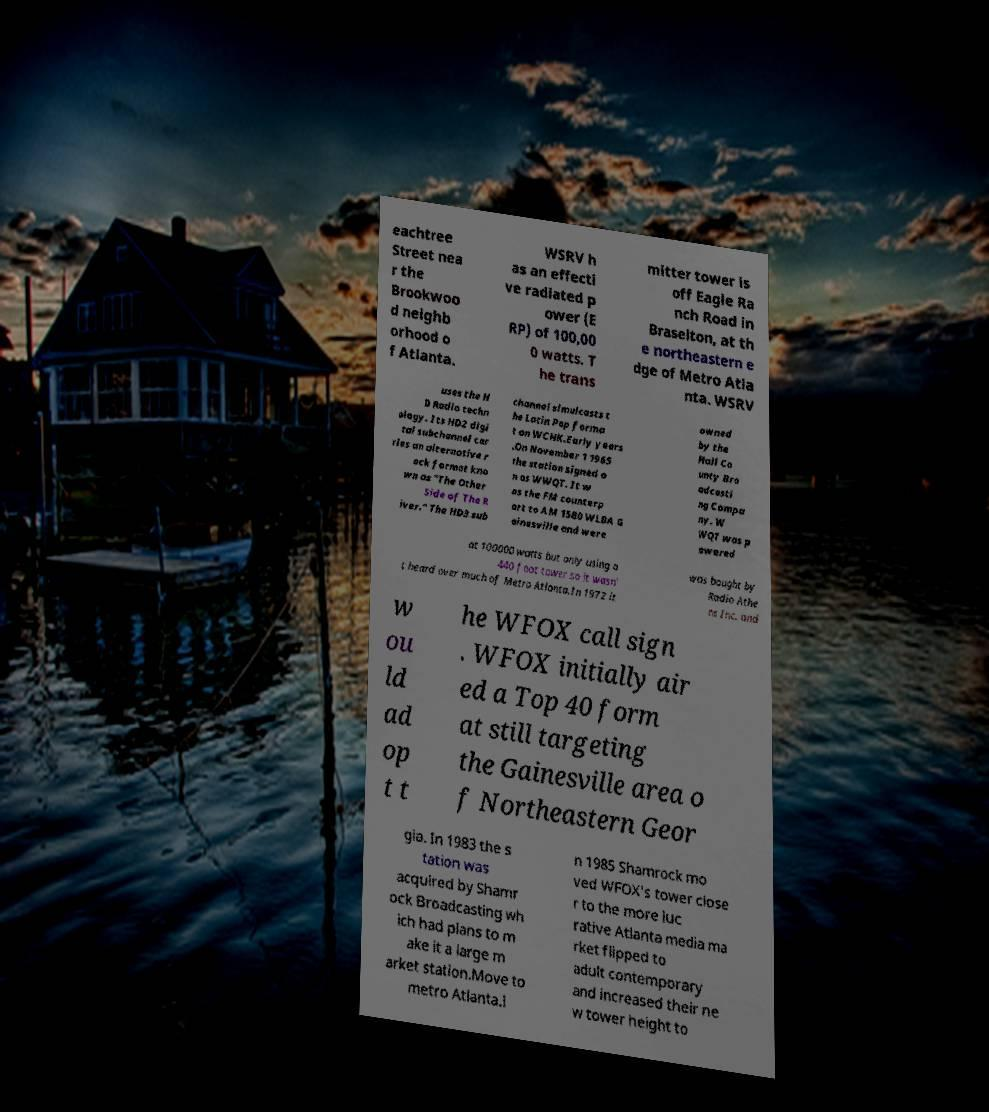Please read and relay the text visible in this image. What does it say? eachtree Street nea r the Brookwoo d neighb orhood o f Atlanta. WSRV h as an effecti ve radiated p ower (E RP) of 100,00 0 watts. T he trans mitter tower is off Eagle Ra nch Road in Braselton, at th e northeastern e dge of Metro Atla nta. WSRV uses the H D Radio techn ology. Its HD2 digi tal subchannel car ries an alternative r ock format kno wn as "The Other Side of The R iver." The HD3 sub channel simulcasts t he Latin Pop forma t on WCHK.Early years .On November 1 1965 the station signed o n as WWQT. It w as the FM counterp art to AM 1580 WLBA G ainesville and were owned by the Hall Co unty Bro adcasti ng Compa ny. W WQT was p owered at 100000 watts but only using a 440 foot tower so it wasn' t heard over much of Metro Atlanta.In 1972 it was bought by Radio Athe ns Inc. and w ou ld ad op t t he WFOX call sign . WFOX initially air ed a Top 40 form at still targeting the Gainesville area o f Northeastern Geor gia. In 1983 the s tation was acquired by Shamr ock Broadcasting wh ich had plans to m ake it a large m arket station.Move to metro Atlanta.I n 1985 Shamrock mo ved WFOX's tower close r to the more luc rative Atlanta media ma rket flipped to adult contemporary and increased their ne w tower height to 